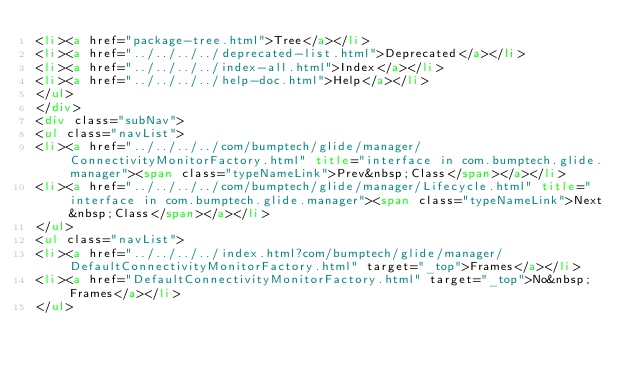<code> <loc_0><loc_0><loc_500><loc_500><_HTML_><li><a href="package-tree.html">Tree</a></li>
<li><a href="../../../../deprecated-list.html">Deprecated</a></li>
<li><a href="../../../../index-all.html">Index</a></li>
<li><a href="../../../../help-doc.html">Help</a></li>
</ul>
</div>
<div class="subNav">
<ul class="navList">
<li><a href="../../../../com/bumptech/glide/manager/ConnectivityMonitorFactory.html" title="interface in com.bumptech.glide.manager"><span class="typeNameLink">Prev&nbsp;Class</span></a></li>
<li><a href="../../../../com/bumptech/glide/manager/Lifecycle.html" title="interface in com.bumptech.glide.manager"><span class="typeNameLink">Next&nbsp;Class</span></a></li>
</ul>
<ul class="navList">
<li><a href="../../../../index.html?com/bumptech/glide/manager/DefaultConnectivityMonitorFactory.html" target="_top">Frames</a></li>
<li><a href="DefaultConnectivityMonitorFactory.html" target="_top">No&nbsp;Frames</a></li>
</ul></code> 